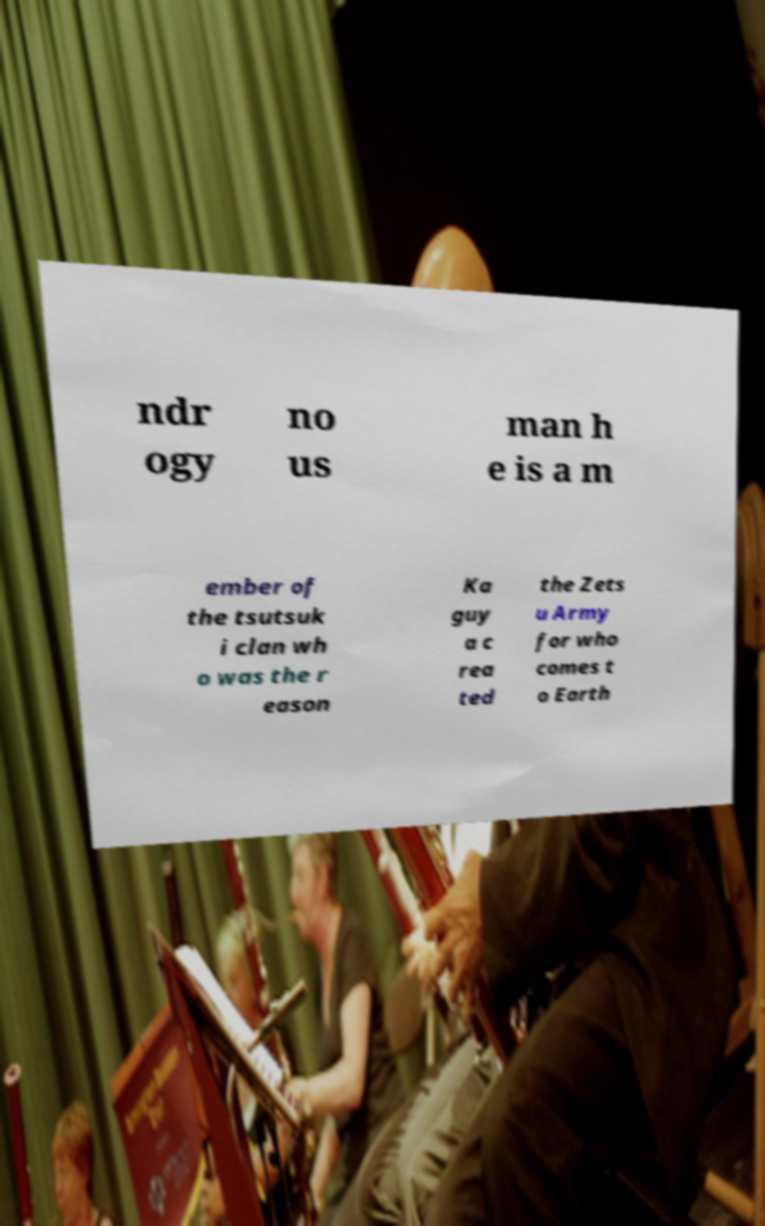Please identify and transcribe the text found in this image. ndr ogy no us man h e is a m ember of the tsutsuk i clan wh o was the r eason Ka guy a c rea ted the Zets u Army for who comes t o Earth 